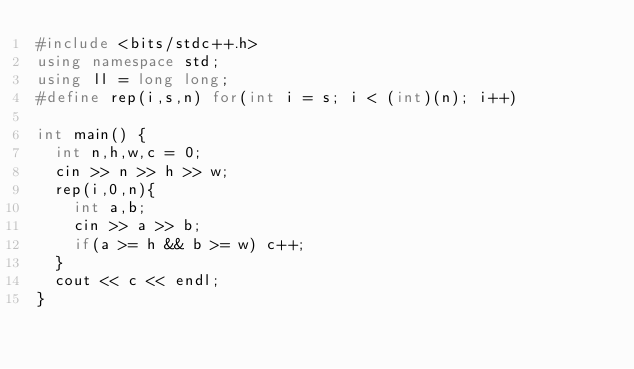<code> <loc_0><loc_0><loc_500><loc_500><_C++_>#include <bits/stdc++.h>
using namespace std;
using ll = long long;
#define rep(i,s,n) for(int i = s; i < (int)(n); i++)

int main() {
  int n,h,w,c = 0;
  cin >> n >> h >> w;
  rep(i,0,n){
    int a,b;
    cin >> a >> b;
    if(a >= h && b >= w) c++;
  }
  cout << c << endl;
}</code> 